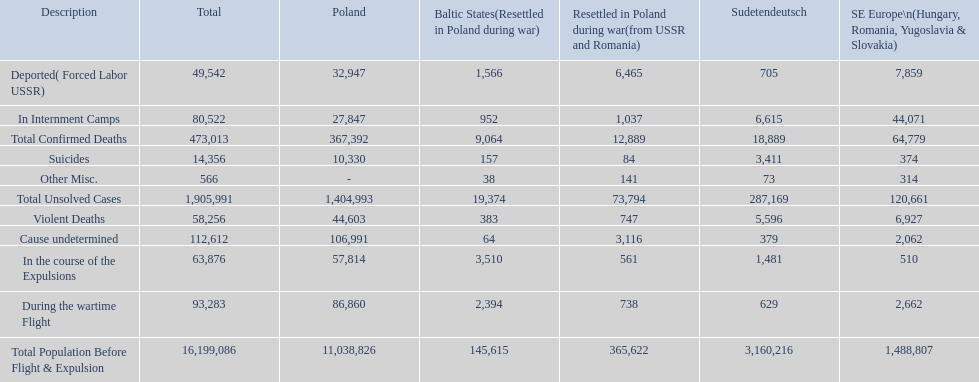What are all of the descriptions? Total Population Before Flight & Expulsion, Violent Deaths, Suicides, Deported( Forced Labor USSR), In Internment Camps, During the wartime Flight, In the course of the Expulsions, Cause undetermined, Other Misc., Total Confirmed Deaths, Total Unsolved Cases. What were their total number of deaths? 16,199,086, 58,256, 14,356, 49,542, 80,522, 93,283, 63,876, 112,612, 566, 473,013, 1,905,991. What about just from violent deaths? 58,256. 